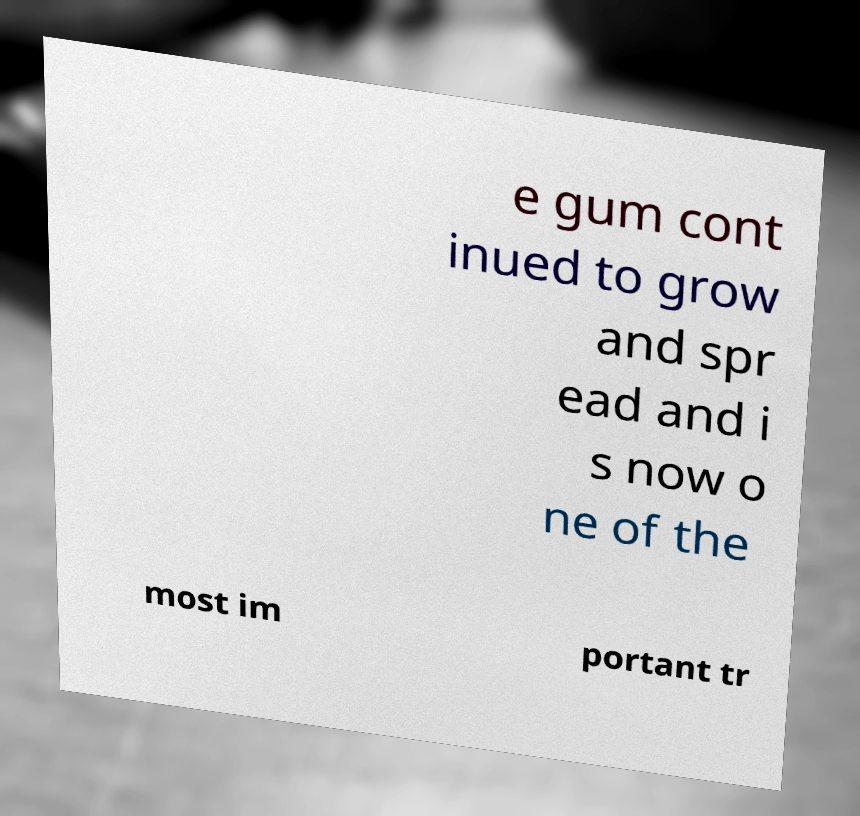Could you extract and type out the text from this image? e gum cont inued to grow and spr ead and i s now o ne of the most im portant tr 